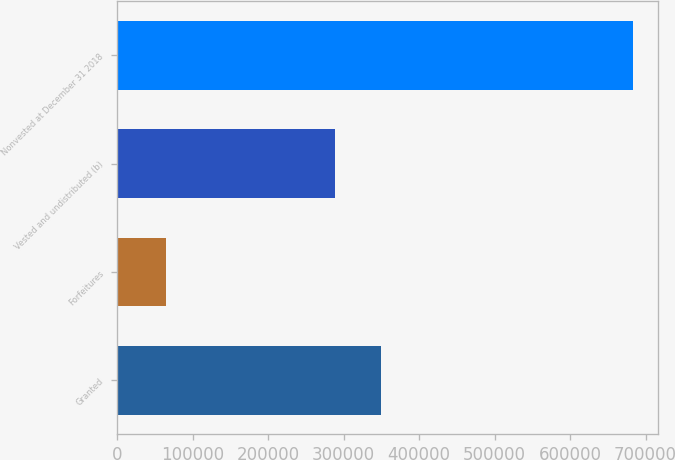Convert chart to OTSL. <chart><loc_0><loc_0><loc_500><loc_500><bar_chart><fcel>Granted<fcel>Forfeitures<fcel>Vested and undistributed (b)<fcel>Nonvested at December 31 2018<nl><fcel>350174<fcel>65106<fcel>288404<fcel>682811<nl></chart> 